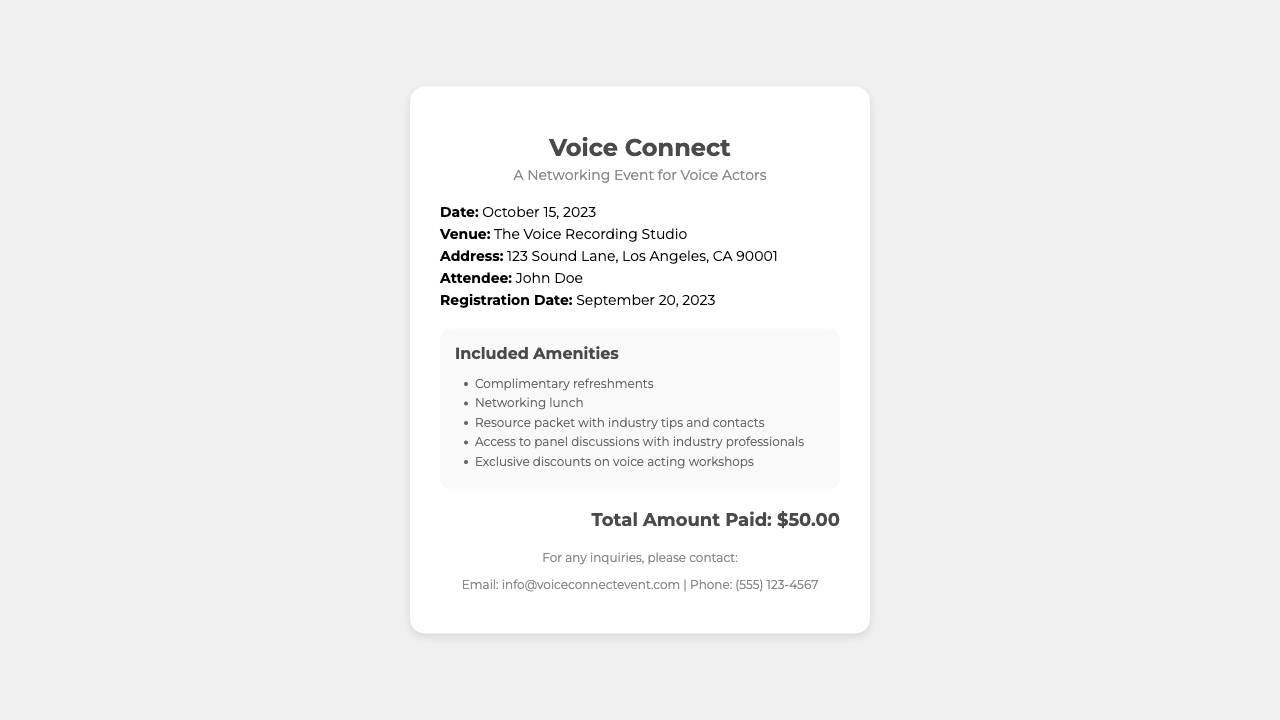What is the title of the event? The title of the event is mentioned at the top of the document, which is "Voice Connect."
Answer: Voice Connect What is the date of the event? The date is specified in the details section of the document as October 15, 2023.
Answer: October 15, 2023 What is the total amount paid? The total amount is clearly indicated in the total section of the document as $50.00.
Answer: $50.00 What is the venue for the event? The venue is provided in the details section, which states "The Voice Recording Studio."
Answer: The Voice Recording Studio What amenities are included? The amenities are listed in a separate section in the document and include complimentary refreshments, among others.
Answer: Complimentary refreshments How many amenities are listed in total? The document lists five amenities provided at the event in the amenities section.
Answer: Five Who is the attendee mentioned in the receipt? The attendee's name is mentioned in the details section as John Doe.
Answer: John Doe When was the registration completed? The registration date is included in the details section of the document and is September 20, 2023.
Answer: September 20, 2023 What is the contact phone number provided? The contact phone number is mentioned in the footer of the document as (555) 123-4567.
Answer: (555) 123-4567 